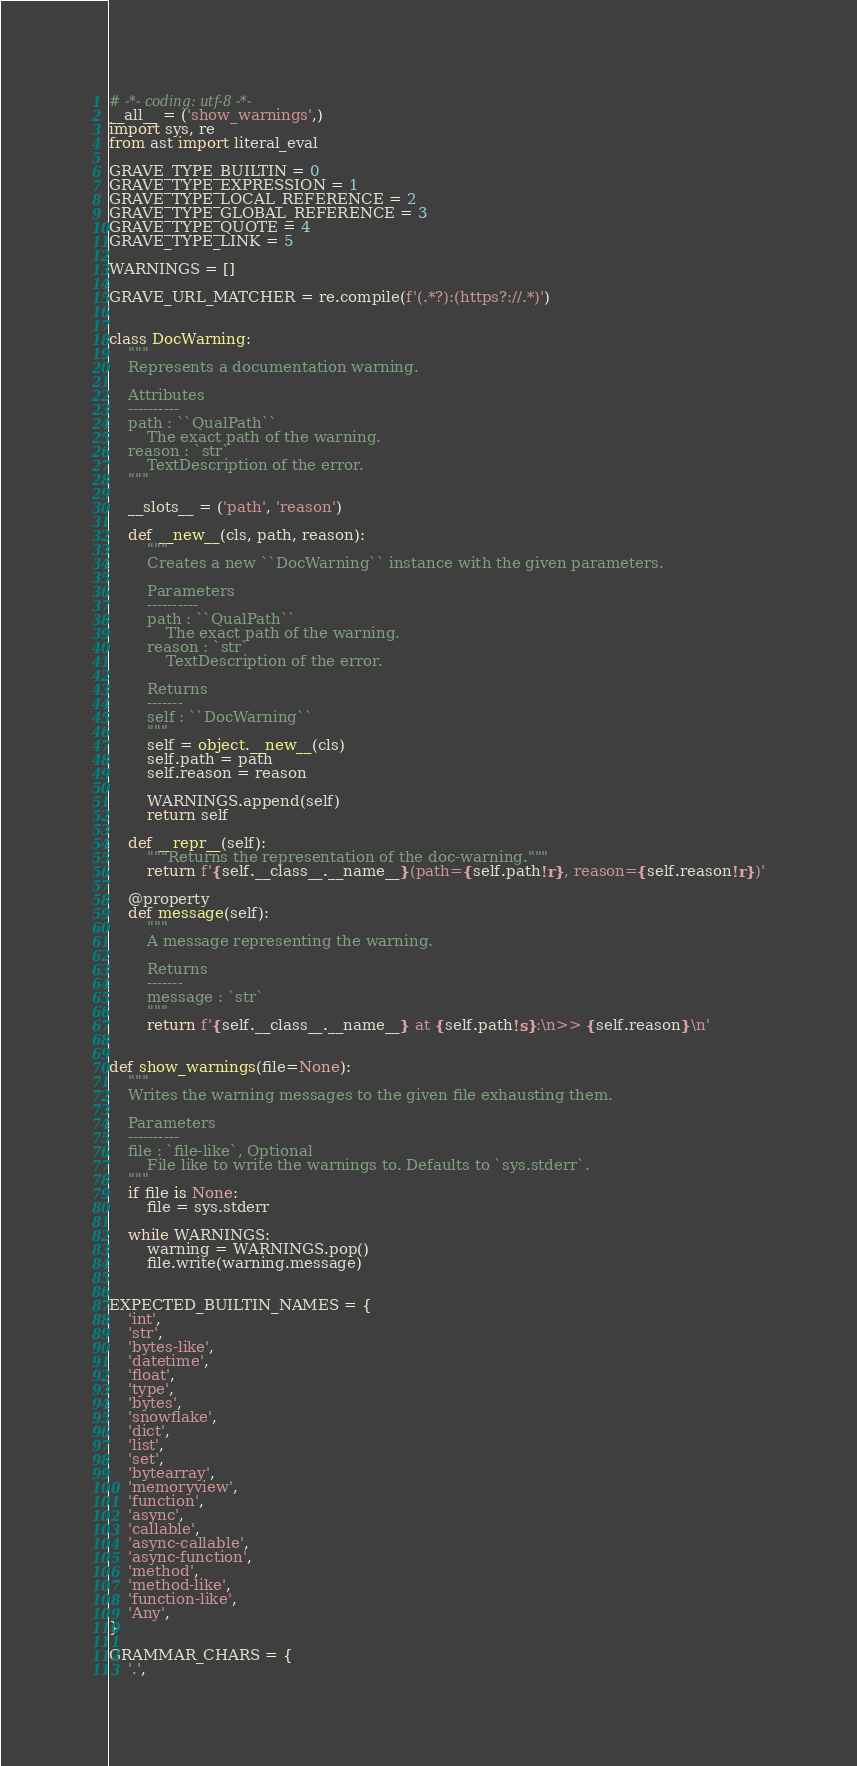<code> <loc_0><loc_0><loc_500><loc_500><_Python_># -*- coding: utf-8 -*-
__all__ = ('show_warnings',)
import sys, re
from ast import literal_eval

GRAVE_TYPE_BUILTIN = 0
GRAVE_TYPE_EXPRESSION = 1
GRAVE_TYPE_LOCAL_REFERENCE = 2
GRAVE_TYPE_GLOBAL_REFERENCE = 3
GRAVE_TYPE_QUOTE = 4
GRAVE_TYPE_LINK = 5

WARNINGS = []

GRAVE_URL_MATCHER = re.compile(f'(.*?):(https?://.*)')


class DocWarning:
    """
    Represents a documentation warning.

    Attributes
    ----------
    path : ``QualPath``
        The exact path of the warning.
    reason : `str`
        TextDescription of the error.
    """

    __slots__ = ('path', 'reason')

    def __new__(cls, path, reason):
        """
        Creates a new ``DocWarning`` instance with the given parameters.

        Parameters
        ----------
        path : ``QualPath``
            The exact path of the warning.
        reason : `str`
            TextDescription of the error.

        Returns
        -------
        self : ``DocWarning``
        """
        self = object.__new__(cls)
        self.path = path
        self.reason = reason

        WARNINGS.append(self)
        return self

    def __repr__(self):
        """Returns the representation of the doc-warning."""
        return f'{self.__class__.__name__}(path={self.path!r}, reason={self.reason!r})'

    @property
    def message(self):
        """
        A message representing the warning.

        Returns
        -------
        message : `str`
        """
        return f'{self.__class__.__name__} at {self.path!s}:\n>> {self.reason}\n'


def show_warnings(file=None):
    """
    Writes the warning messages to the given file exhausting them.

    Parameters
    ----------
    file : `file-like`, Optional
        File like to write the warnings to. Defaults to `sys.stderr`.
    """
    if file is None:
        file = sys.stderr

    while WARNINGS:
        warning = WARNINGS.pop()
        file.write(warning.message)


EXPECTED_BUILTIN_NAMES = {
    'int',
    'str',
    'bytes-like',
    'datetime',
    'float',
    'type',
    'bytes',
    'snowflake',
    'dict',
    'list',
    'set',
    'bytearray',
    'memoryview',
    'function',
    'async',
    'callable',
    'async-callable',
    'async-function',
    'method',
    'method-like',
    'function-like',
    'Any',
}

GRAMMAR_CHARS = {
    '.',</code> 